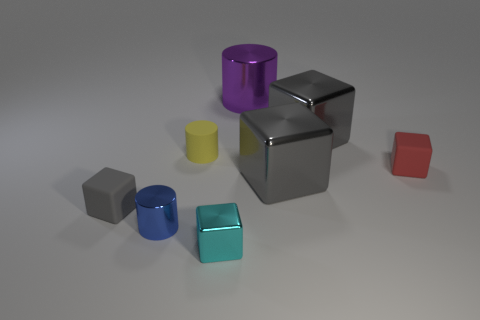How many cyan shiny blocks are the same size as the yellow cylinder? There is one cyan shiny block that is the same size as the yellow cylinder. The block shares the same height and rectangular base dimensions, creating a visually pleasing symmetry when they are compared side by side. 